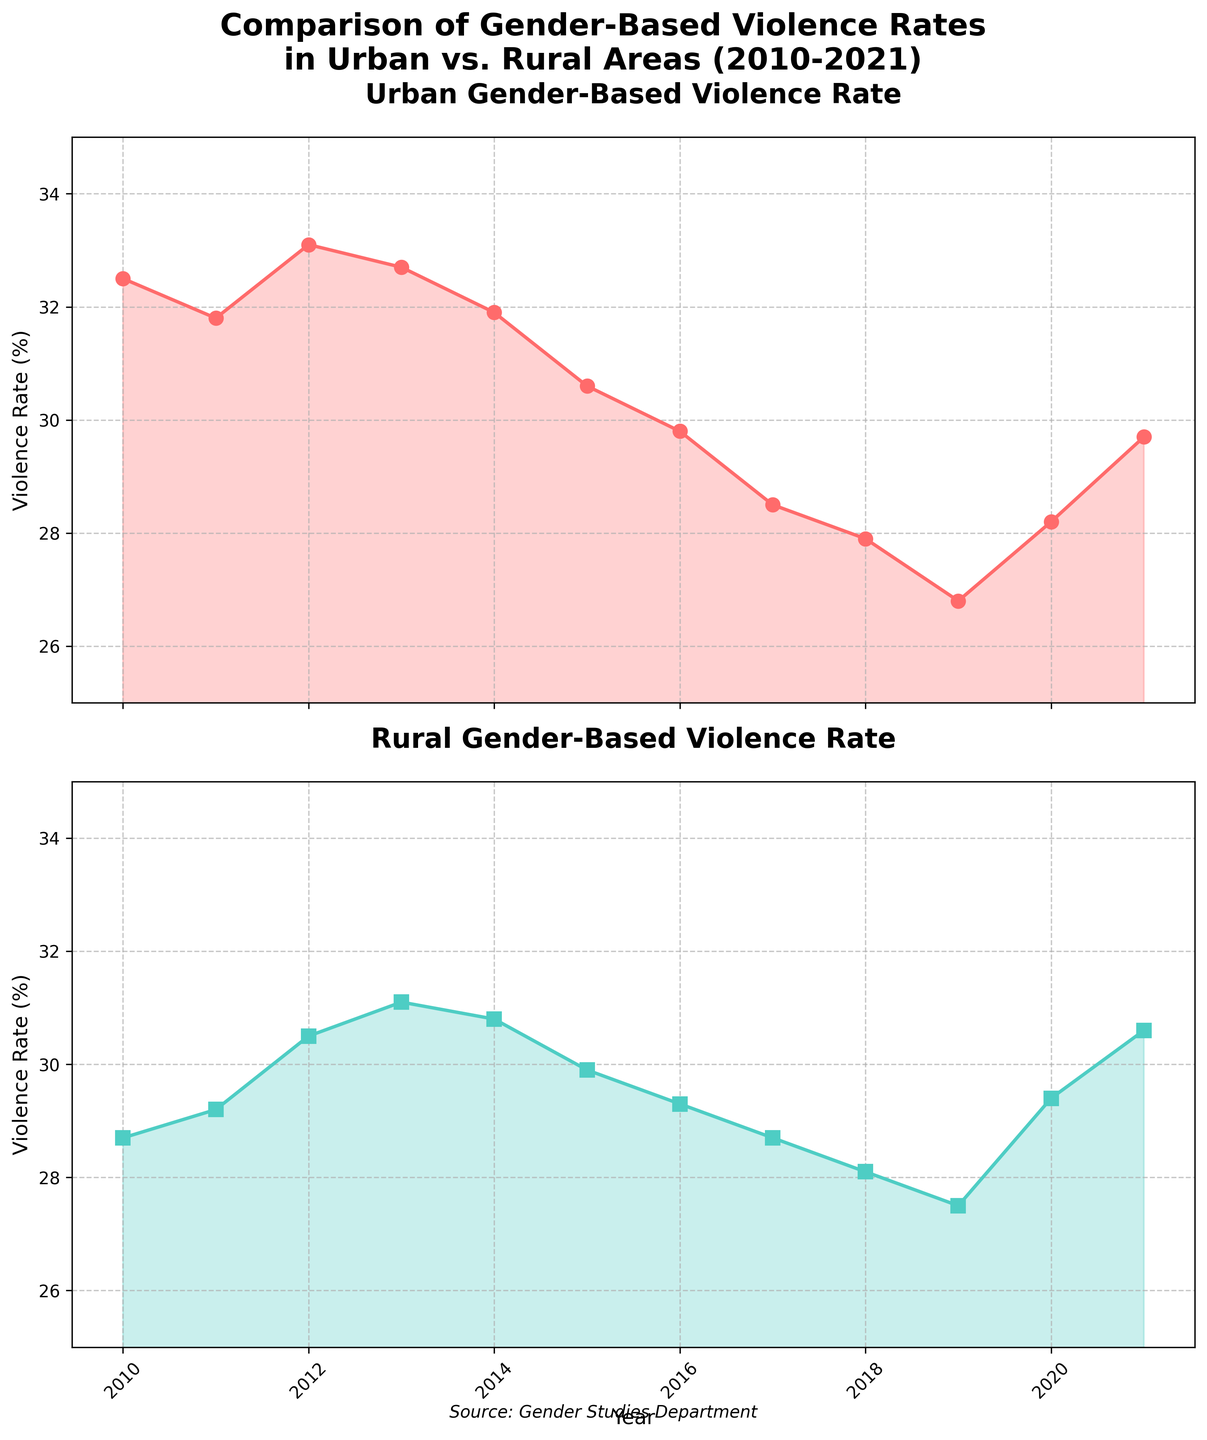Which year had the highest urban gender-based violence rate? From the plot of Urban Gender-Based Violence Rate, the highest point occurs where the line is at its peak. The peak value is at 2012.
Answer: 2012 What is the overall trend in rural gender-based violence rates between 2010 to 2021? In the plot of Rural Gender-Based Violence Rate, the rates initially increase until 2013, decrease steadily until 2019, and then increase again from 2019 to 2021.
Answer: Initial increase, then decrease, followed by another increase Does urban gender-based violence rate ever fall below rural rates between 2010 to 2021? By comparing the heights of the lines in both subplots across the years, the urban rate does fall below the rural rate in 2020.
Answer: 2020 What is the difference in urban violence rates between the highest and the lowest years within the period? The highest urban violence rate is 33.1% in 2012, and the lowest is 26.8% in 2019. The difference is 33.1 - 26.8 = 6.3%.
Answer: 6.3% Which year shows the smallest gap between urban and rural gender-based violence rates? Look for the year where the lines of both subplots are closest together. In 2011, the gap is smallest (31.8 - 29.2 = 2.6%).
Answer: 2011 What is the average rural gender-based violence rate from 2010 to 2021? Sum all the yearly rural rates and divide by the total number of years. (28.7 + 29.2 + 30.5 + 31.1 + 30.8 + 29.9 + 29.3 + 28.7 + 28.1 + 27.5 + 29.4 + 30.6) / 12 = 29.65%.
Answer: 29.65% How many years did the urban violence rate decrease consecutively? Evaluate the plot from one year to the next. The rate decreases consecutively from 2013 to 2019, which makes it 6 consecutive years.
Answer: 6 years Is there any year where the urban rate increased but the rural rate decreased? Compare the slopes in the two subplots for each year. In 2020, the urban rate increased while the rural rate decreased.
Answer: 2020 What is the combined violence rate percentage (urban + rural) in 2015? Add the urban and rural violence rates for 2015. Urban: 30.6%, Rural: 29.9%. Combined rate is 30.6 + 29.9 = 60.5%.
Answer: 60.5% By how much did the urban gender-based violence rate change from 2010 to 2021? Subtract the urban rate in 2021 from the rate in 2010. The change is 29.7 - 32.5 = -2.8%.
Answer: -2.8% 